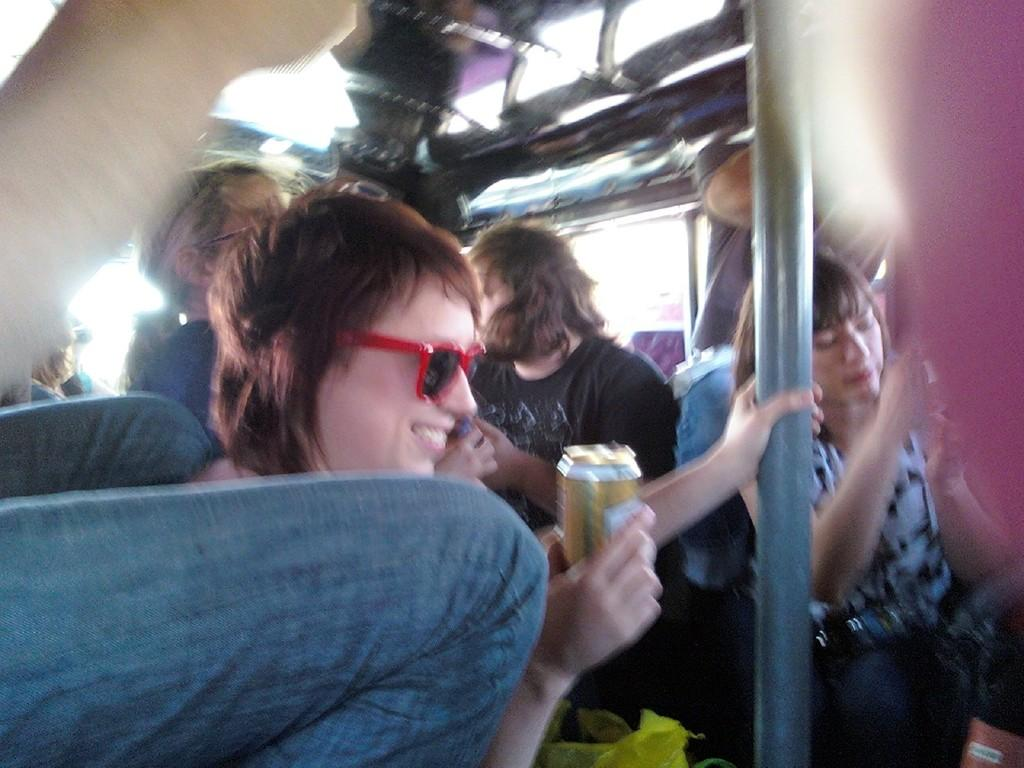What is the person in the image wearing on their face? The person is wearing glasses in the image. What is the person holding in their hands? The person is holding a tin in their hands. What is the facial expression of the person in the image? The person is smiling in the image. Are there any other people visible in the image? Yes, there are other people visible in the image. What object can be seen standing upright in the image? There is a pole in the image. What type of hose is being used by the person in the image? There is no hose present in the image. Can you tell me the color of the heart that the person is holding in the image? There is no heart present in the image; the person is holding a tin. 